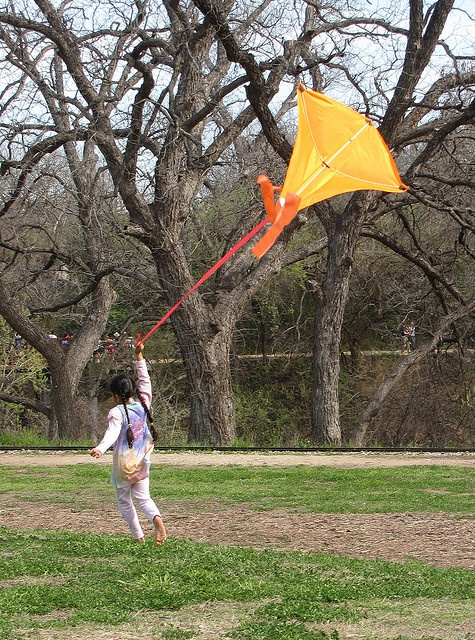Describe the objects in this image and their specific colors. I can see kite in white, gold, orange, salmon, and red tones, people in white, darkgray, black, and gray tones, handbag in white, ivory, gray, and tan tones, and people in white, black, gray, and darkgray tones in this image. 